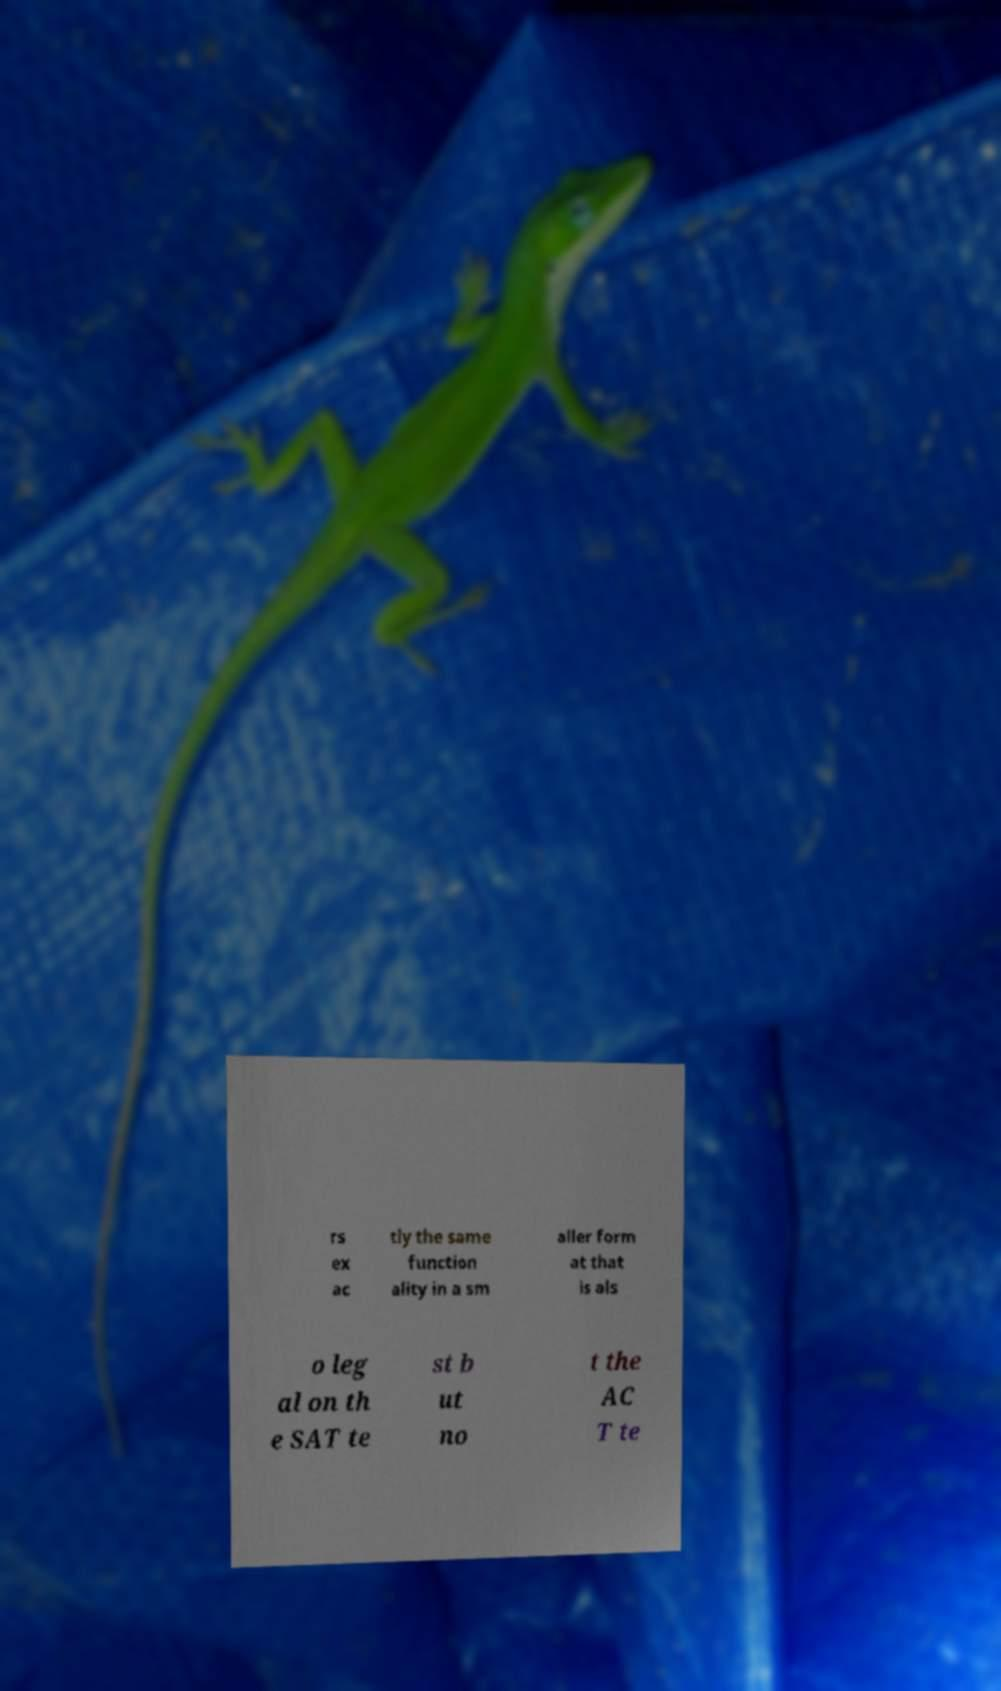I need the written content from this picture converted into text. Can you do that? rs ex ac tly the same function ality in a sm aller form at that is als o leg al on th e SAT te st b ut no t the AC T te 